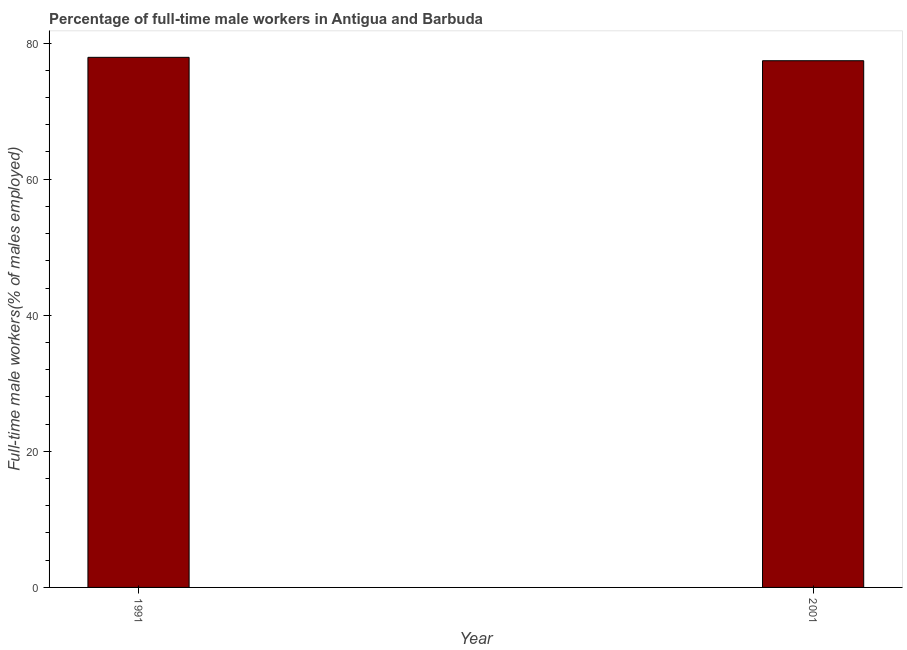Does the graph contain any zero values?
Provide a succinct answer. No. What is the title of the graph?
Your answer should be very brief. Percentage of full-time male workers in Antigua and Barbuda. What is the label or title of the X-axis?
Give a very brief answer. Year. What is the label or title of the Y-axis?
Keep it short and to the point. Full-time male workers(% of males employed). What is the percentage of full-time male workers in 2001?
Offer a very short reply. 77.4. Across all years, what is the maximum percentage of full-time male workers?
Offer a very short reply. 77.9. Across all years, what is the minimum percentage of full-time male workers?
Ensure brevity in your answer.  77.4. What is the sum of the percentage of full-time male workers?
Make the answer very short. 155.3. What is the average percentage of full-time male workers per year?
Make the answer very short. 77.65. What is the median percentage of full-time male workers?
Make the answer very short. 77.65. In how many years, is the percentage of full-time male workers greater than 68 %?
Provide a succinct answer. 2. Is the percentage of full-time male workers in 1991 less than that in 2001?
Provide a succinct answer. No. In how many years, is the percentage of full-time male workers greater than the average percentage of full-time male workers taken over all years?
Your response must be concise. 1. How many bars are there?
Give a very brief answer. 2. Are all the bars in the graph horizontal?
Keep it short and to the point. No. What is the difference between two consecutive major ticks on the Y-axis?
Your response must be concise. 20. What is the Full-time male workers(% of males employed) in 1991?
Offer a very short reply. 77.9. What is the Full-time male workers(% of males employed) of 2001?
Provide a succinct answer. 77.4. What is the ratio of the Full-time male workers(% of males employed) in 1991 to that in 2001?
Provide a succinct answer. 1.01. 